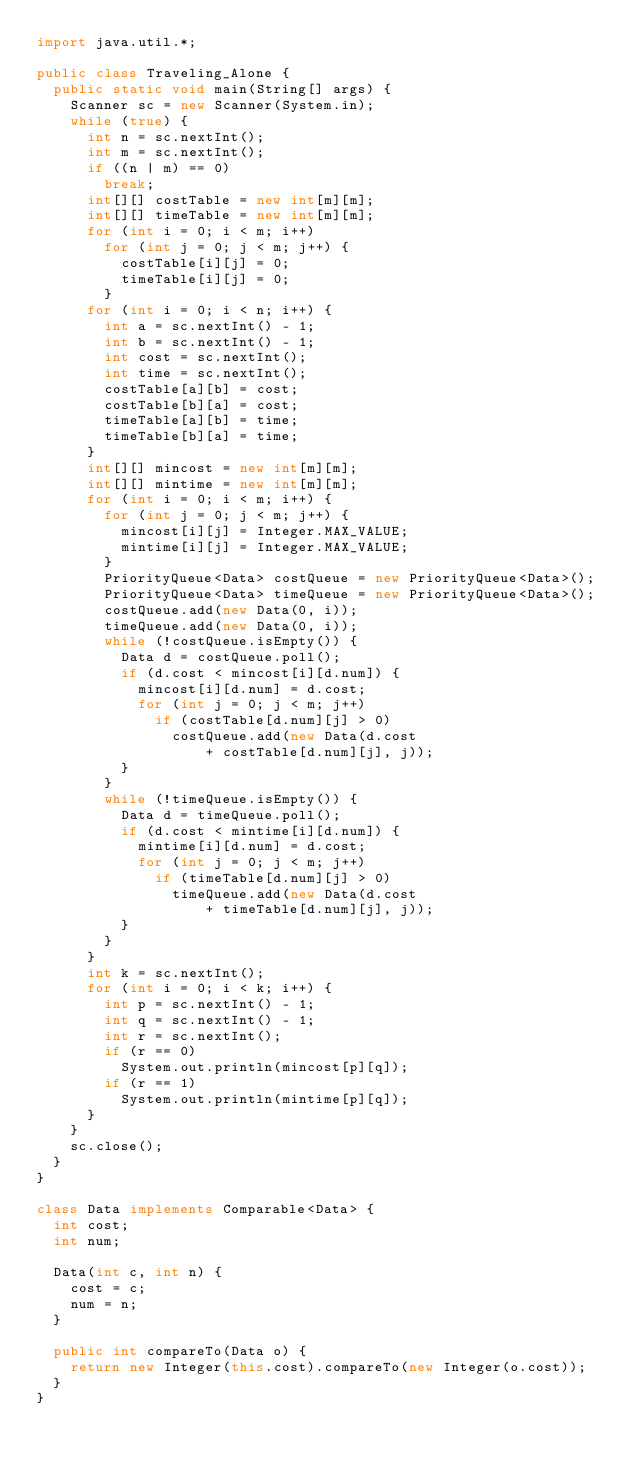<code> <loc_0><loc_0><loc_500><loc_500><_Java_>import java.util.*;

public class Traveling_Alone {
	public static void main(String[] args) {
		Scanner sc = new Scanner(System.in);
		while (true) {
			int n = sc.nextInt();
			int m = sc.nextInt();
			if ((n | m) == 0)
				break;
			int[][] costTable = new int[m][m];
			int[][] timeTable = new int[m][m];
			for (int i = 0; i < m; i++)
				for (int j = 0; j < m; j++) {
					costTable[i][j] = 0;
					timeTable[i][j] = 0;
				}
			for (int i = 0; i < n; i++) {
				int a = sc.nextInt() - 1;
				int b = sc.nextInt() - 1;
				int cost = sc.nextInt();
				int time = sc.nextInt();
				costTable[a][b] = cost;
				costTable[b][a] = cost;
				timeTable[a][b] = time;
				timeTable[b][a] = time;
			}
			int[][] mincost = new int[m][m];
			int[][] mintime = new int[m][m];
			for (int i = 0; i < m; i++) {
				for (int j = 0; j < m; j++) {
					mincost[i][j] = Integer.MAX_VALUE;
					mintime[i][j] = Integer.MAX_VALUE;
				}
				PriorityQueue<Data> costQueue = new PriorityQueue<Data>();
				PriorityQueue<Data> timeQueue = new PriorityQueue<Data>();
				costQueue.add(new Data(0, i));
				timeQueue.add(new Data(0, i));
				while (!costQueue.isEmpty()) {
					Data d = costQueue.poll();
					if (d.cost < mincost[i][d.num]) {
						mincost[i][d.num] = d.cost;
						for (int j = 0; j < m; j++)
							if (costTable[d.num][j] > 0)
								costQueue.add(new Data(d.cost
										+ costTable[d.num][j], j));
					}
				}
				while (!timeQueue.isEmpty()) {
					Data d = timeQueue.poll();
					if (d.cost < mintime[i][d.num]) {
						mintime[i][d.num] = d.cost;
						for (int j = 0; j < m; j++)
							if (timeTable[d.num][j] > 0)
								timeQueue.add(new Data(d.cost
										+ timeTable[d.num][j], j));
					}
				}
			}
			int k = sc.nextInt();
			for (int i = 0; i < k; i++) {
				int p = sc.nextInt() - 1;
				int q = sc.nextInt() - 1;
				int r = sc.nextInt();
				if (r == 0)
					System.out.println(mincost[p][q]);
				if (r == 1)
					System.out.println(mintime[p][q]);
			}
		}
		sc.close();
	}
}

class Data implements Comparable<Data> {
	int cost;
	int num;

	Data(int c, int n) {
		cost = c;
		num = n;
	}

	public int compareTo(Data o) {
		return new Integer(this.cost).compareTo(new Integer(o.cost));
	}
}</code> 